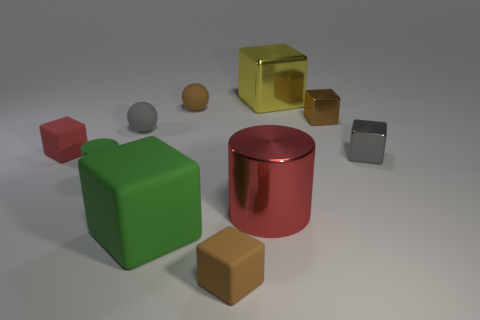Is the small green thing made of the same material as the gray thing behind the tiny gray cube?
Provide a short and direct response. Yes. What color is the small rubber cube that is on the left side of the rubber cylinder that is left of the tiny gray thing behind the tiny gray shiny cube?
Ensure brevity in your answer.  Red. Is there anything else that is the same shape as the red rubber object?
Keep it short and to the point. Yes. Are there more yellow metal objects than matte blocks?
Provide a succinct answer. No. What number of cubes are on the right side of the large rubber thing and in front of the small green object?
Your answer should be compact. 1. What number of small spheres are in front of the brown cube behind the big red metal thing?
Offer a terse response. 1. There is a red object that is to the right of the tiny red cube; does it have the same size as the brown matte object that is to the right of the brown sphere?
Your response must be concise. No. How many tiny gray balls are there?
Give a very brief answer. 1. What number of yellow blocks are the same material as the gray block?
Your response must be concise. 1. Is the number of large green rubber things that are behind the tiny gray ball the same as the number of big cyan matte spheres?
Offer a terse response. Yes. 